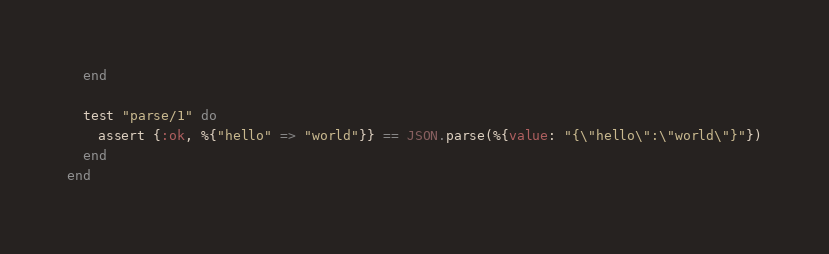Convert code to text. <code><loc_0><loc_0><loc_500><loc_500><_Elixir_>  end

  test "parse/1" do
    assert {:ok, %{"hello" => "world"}} == JSON.parse(%{value: "{\"hello\":\"world\"}"})
  end
end
</code> 